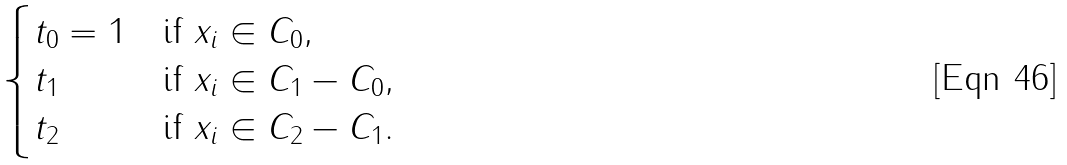Convert formula to latex. <formula><loc_0><loc_0><loc_500><loc_500>\begin{cases} t _ { 0 } = 1 & \text {if $x_{i}\in C_{0}$} , \\ t _ { 1 } & \text {if $x_{i}\in C_{1}-C_{0}$} , \\ t _ { 2 } & \text {if $x_{i}\in C_{2}-C_{1}$} . \end{cases}</formula> 